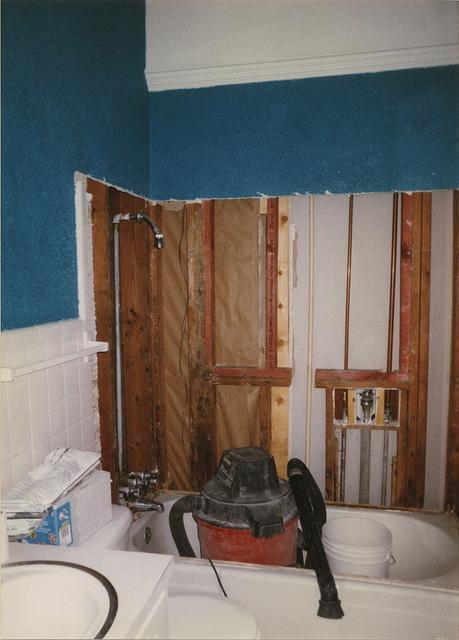Why did they open up the wall?
Indicate the correct response by choosing from the four available options to answer the question.
Options: Leak, decoration, styling, for fun. Leak. 